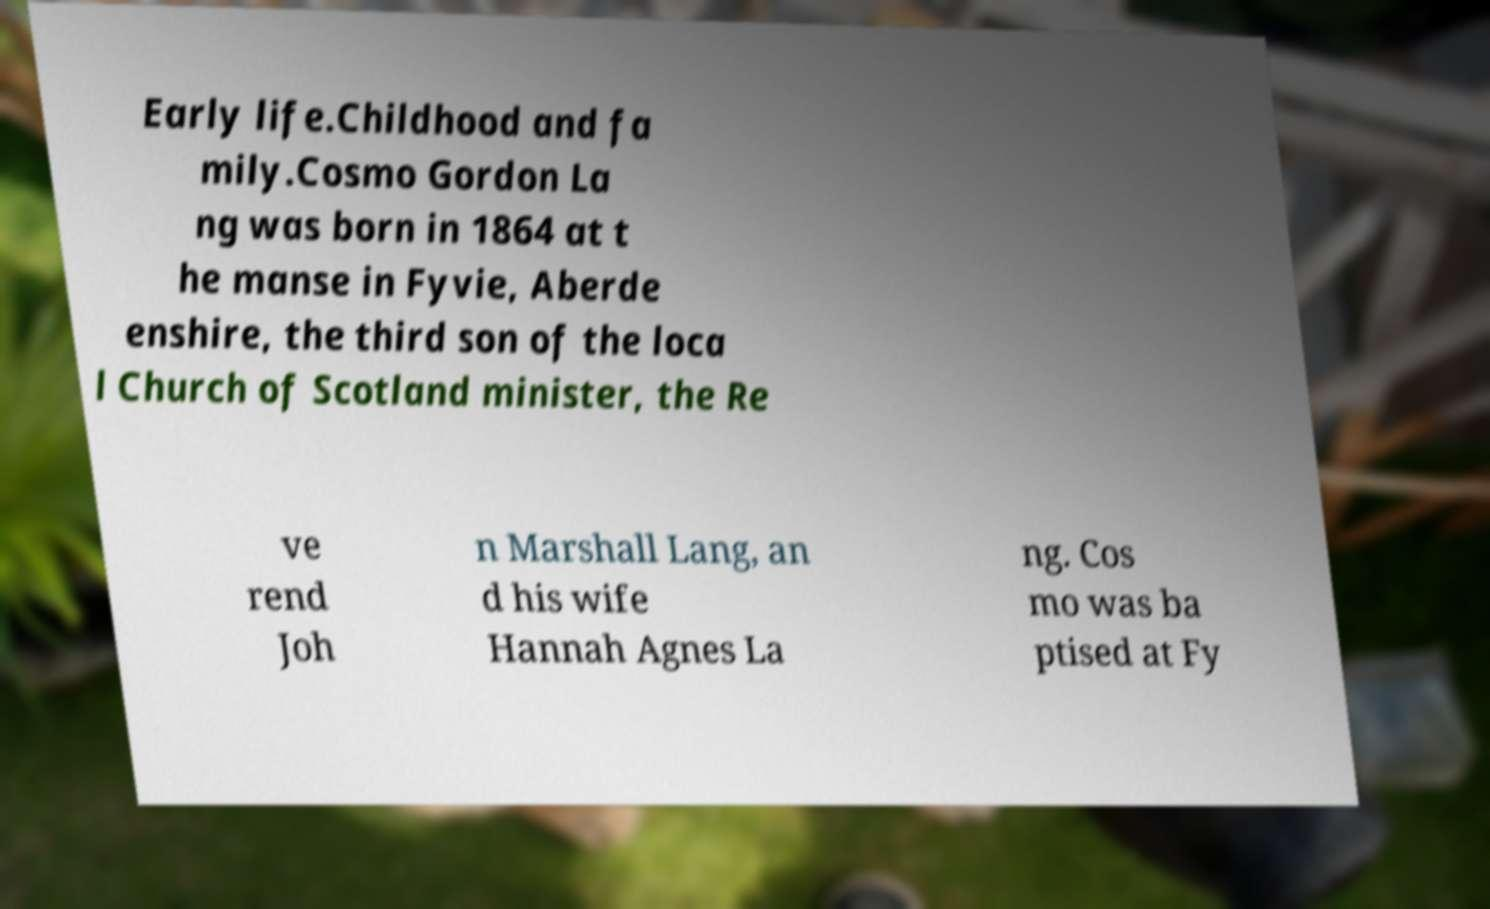There's text embedded in this image that I need extracted. Can you transcribe it verbatim? Early life.Childhood and fa mily.Cosmo Gordon La ng was born in 1864 at t he manse in Fyvie, Aberde enshire, the third son of the loca l Church of Scotland minister, the Re ve rend Joh n Marshall Lang, an d his wife Hannah Agnes La ng. Cos mo was ba ptised at Fy 